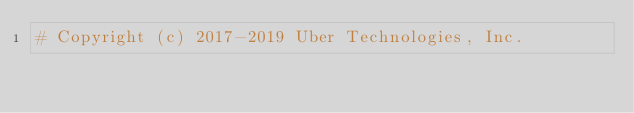Convert code to text. <code><loc_0><loc_0><loc_500><loc_500><_Python_># Copyright (c) 2017-2019 Uber Technologies, Inc.</code> 